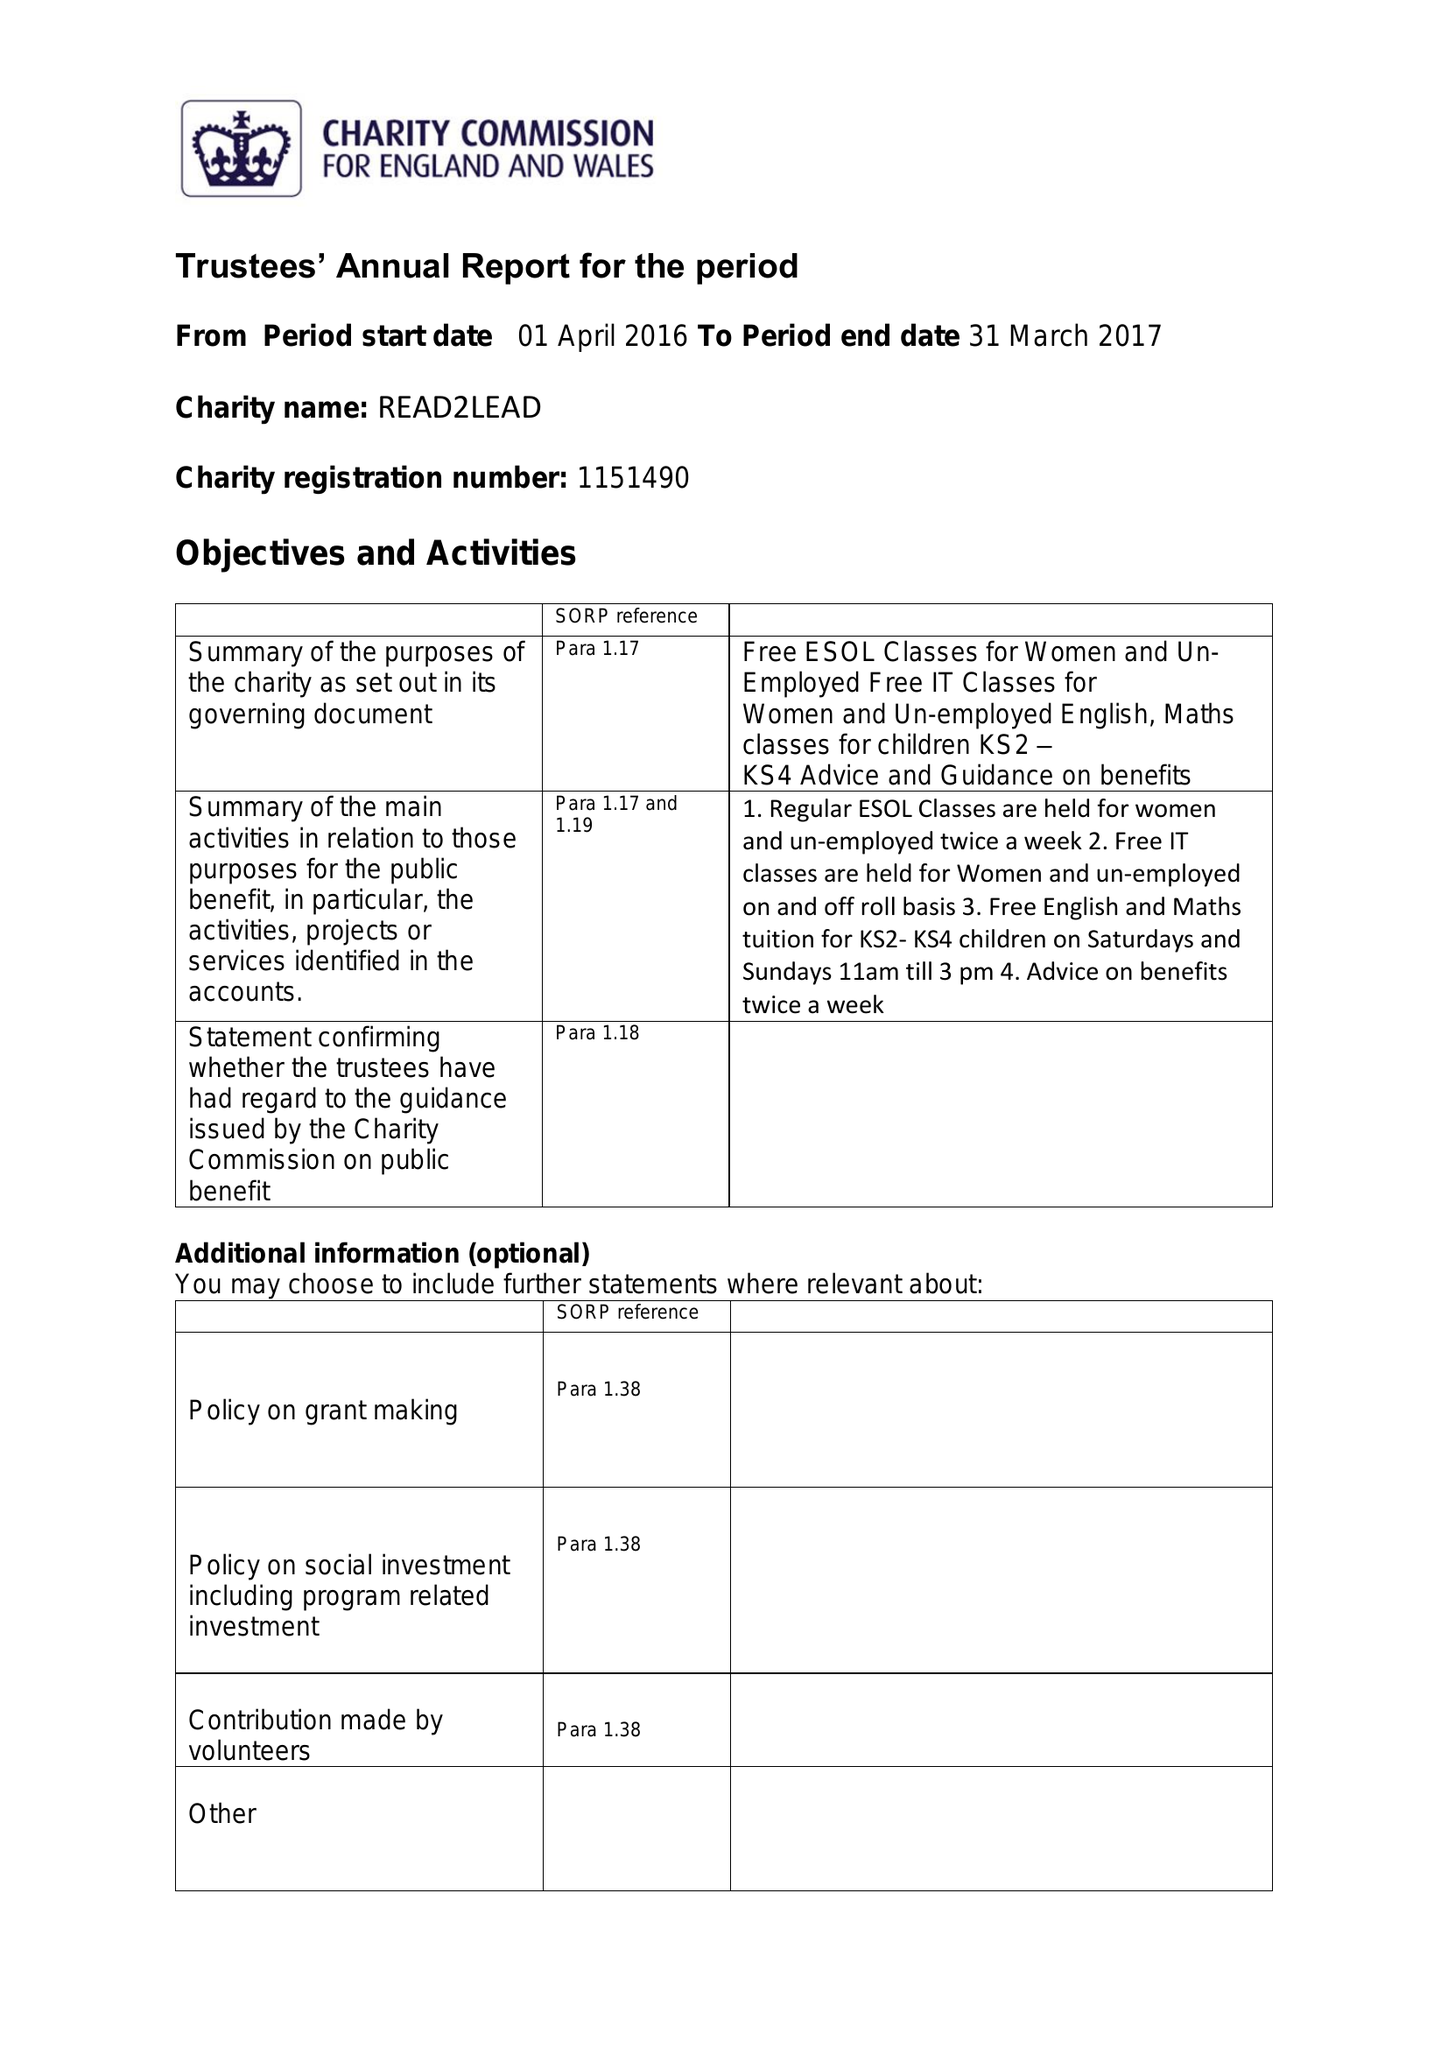What is the value for the income_annually_in_british_pounds?
Answer the question using a single word or phrase. 19675.00 